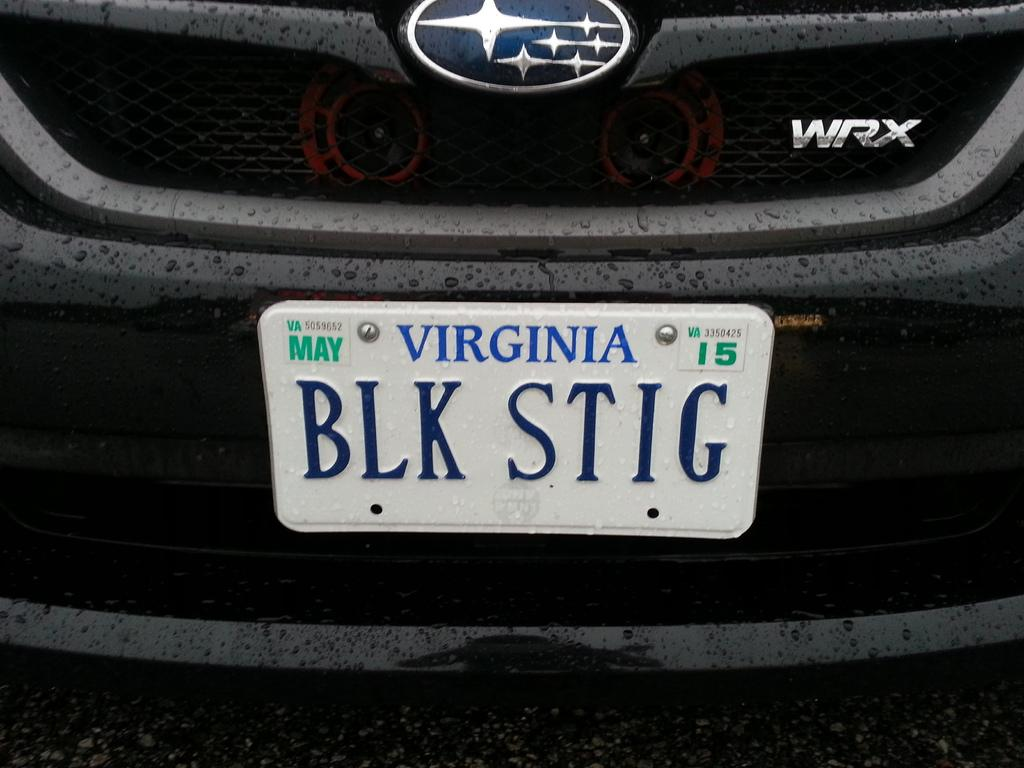<image>
Describe the image concisely. A Virginia license plate number BLK STIG expired in May 2015. 